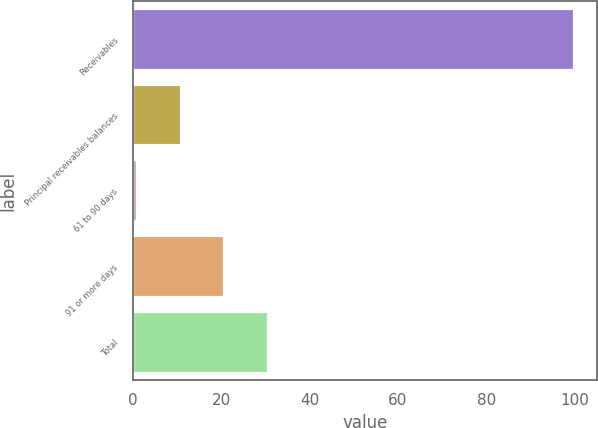<chart> <loc_0><loc_0><loc_500><loc_500><bar_chart><fcel>Receivables<fcel>Principal receivables balances<fcel>61 to 90 days<fcel>91 or more days<fcel>Total<nl><fcel>100<fcel>10.81<fcel>0.9<fcel>20.72<fcel>30.63<nl></chart> 